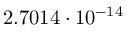Convert formula to latex. <formula><loc_0><loc_0><loc_500><loc_500>2 . 7 0 1 4 \cdot 1 0 ^ { - 1 4 }</formula> 